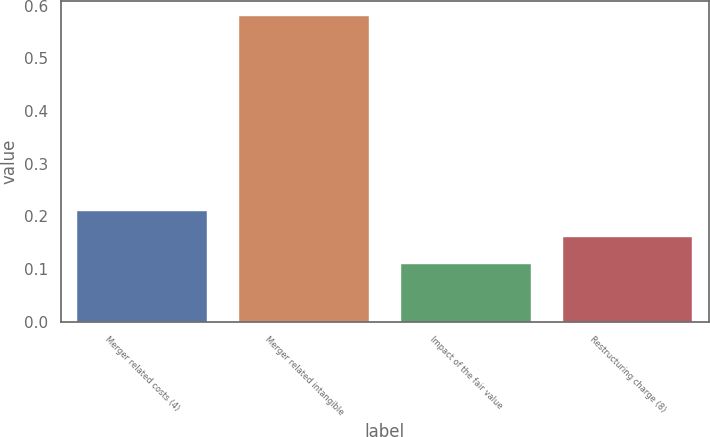Convert chart. <chart><loc_0><loc_0><loc_500><loc_500><bar_chart><fcel>Merger related costs (4)<fcel>Merger related intangible<fcel>Impact of the fair value<fcel>Restructuring charge (8)<nl><fcel>0.21<fcel>0.58<fcel>0.11<fcel>0.16<nl></chart> 